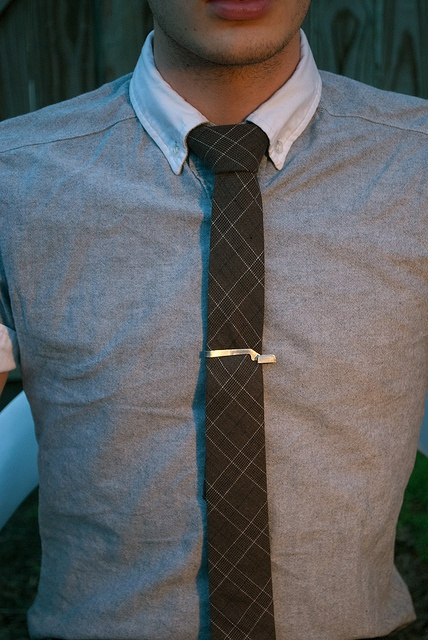Describe the objects in this image and their specific colors. I can see people in gray and black tones and tie in black and gray tones in this image. 